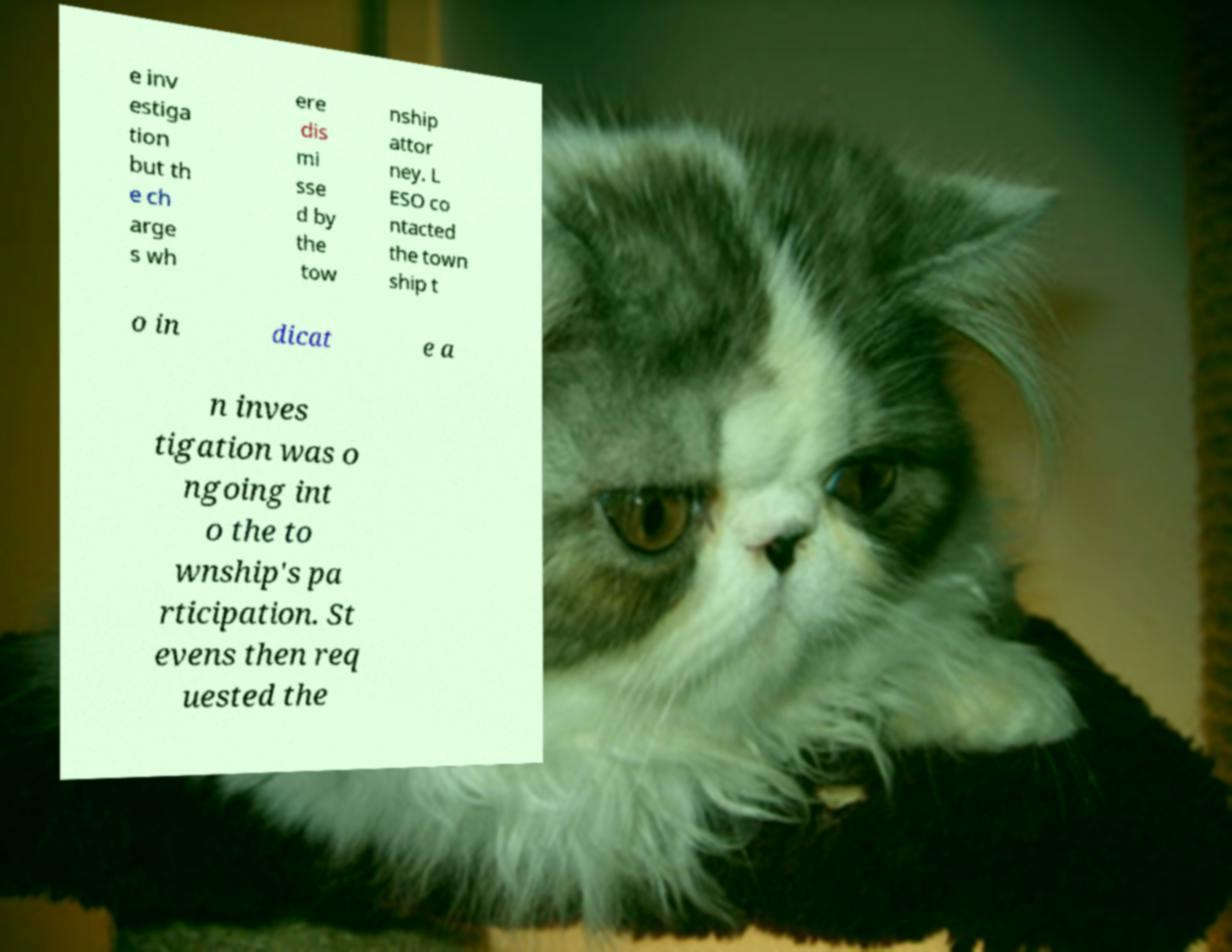For documentation purposes, I need the text within this image transcribed. Could you provide that? e inv estiga tion but th e ch arge s wh ere dis mi sse d by the tow nship attor ney. L ESO co ntacted the town ship t o in dicat e a n inves tigation was o ngoing int o the to wnship's pa rticipation. St evens then req uested the 